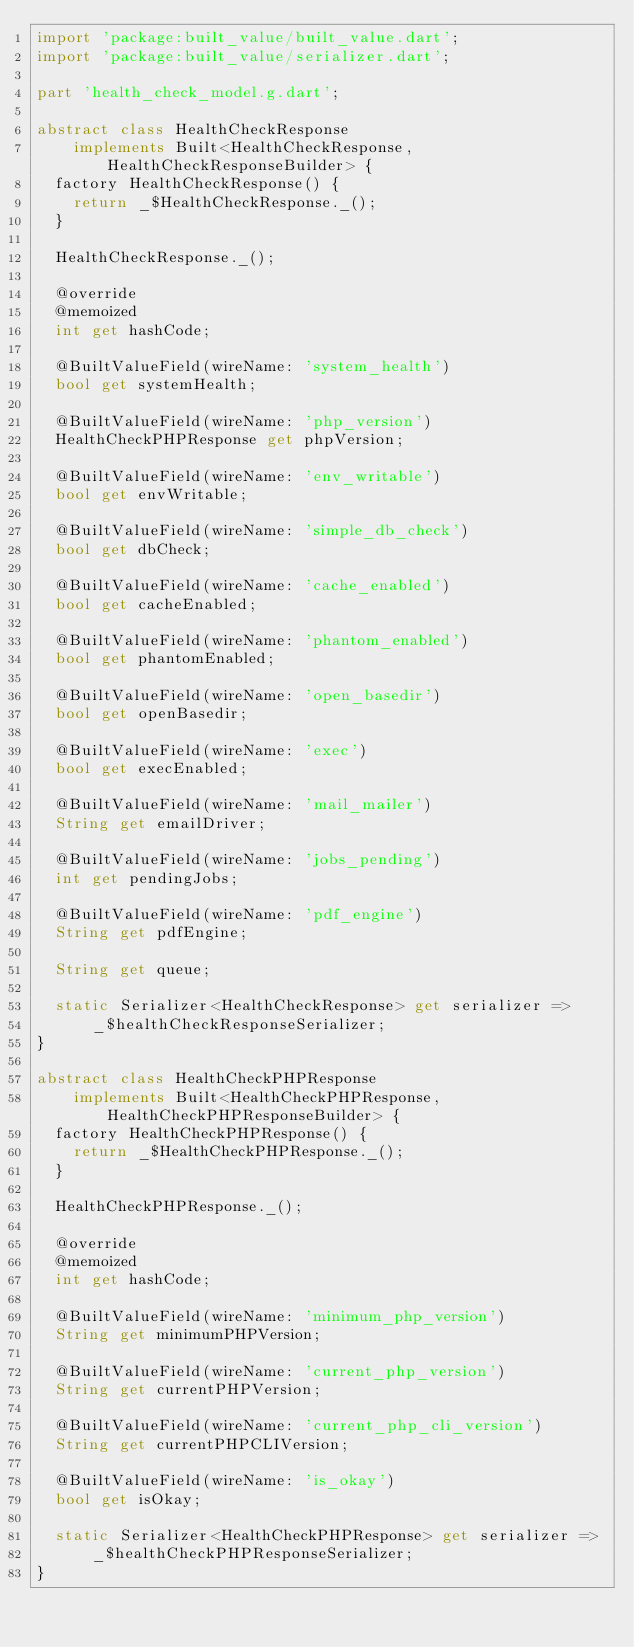<code> <loc_0><loc_0><loc_500><loc_500><_Dart_>import 'package:built_value/built_value.dart';
import 'package:built_value/serializer.dart';

part 'health_check_model.g.dart';

abstract class HealthCheckResponse
    implements Built<HealthCheckResponse, HealthCheckResponseBuilder> {
  factory HealthCheckResponse() {
    return _$HealthCheckResponse._();
  }

  HealthCheckResponse._();

  @override
  @memoized
  int get hashCode;

  @BuiltValueField(wireName: 'system_health')
  bool get systemHealth;

  @BuiltValueField(wireName: 'php_version')
  HealthCheckPHPResponse get phpVersion;

  @BuiltValueField(wireName: 'env_writable')
  bool get envWritable;

  @BuiltValueField(wireName: 'simple_db_check')
  bool get dbCheck;

  @BuiltValueField(wireName: 'cache_enabled')
  bool get cacheEnabled;

  @BuiltValueField(wireName: 'phantom_enabled')
  bool get phantomEnabled;

  @BuiltValueField(wireName: 'open_basedir')
  bool get openBasedir;

  @BuiltValueField(wireName: 'exec')
  bool get execEnabled;

  @BuiltValueField(wireName: 'mail_mailer')
  String get emailDriver;

  @BuiltValueField(wireName: 'jobs_pending')
  int get pendingJobs;

  @BuiltValueField(wireName: 'pdf_engine')
  String get pdfEngine;

  String get queue;

  static Serializer<HealthCheckResponse> get serializer =>
      _$healthCheckResponseSerializer;
}

abstract class HealthCheckPHPResponse
    implements Built<HealthCheckPHPResponse, HealthCheckPHPResponseBuilder> {
  factory HealthCheckPHPResponse() {
    return _$HealthCheckPHPResponse._();
  }

  HealthCheckPHPResponse._();

  @override
  @memoized
  int get hashCode;

  @BuiltValueField(wireName: 'minimum_php_version')
  String get minimumPHPVersion;

  @BuiltValueField(wireName: 'current_php_version')
  String get currentPHPVersion;

  @BuiltValueField(wireName: 'current_php_cli_version')
  String get currentPHPCLIVersion;

  @BuiltValueField(wireName: 'is_okay')
  bool get isOkay;

  static Serializer<HealthCheckPHPResponse> get serializer =>
      _$healthCheckPHPResponseSerializer;
}
</code> 